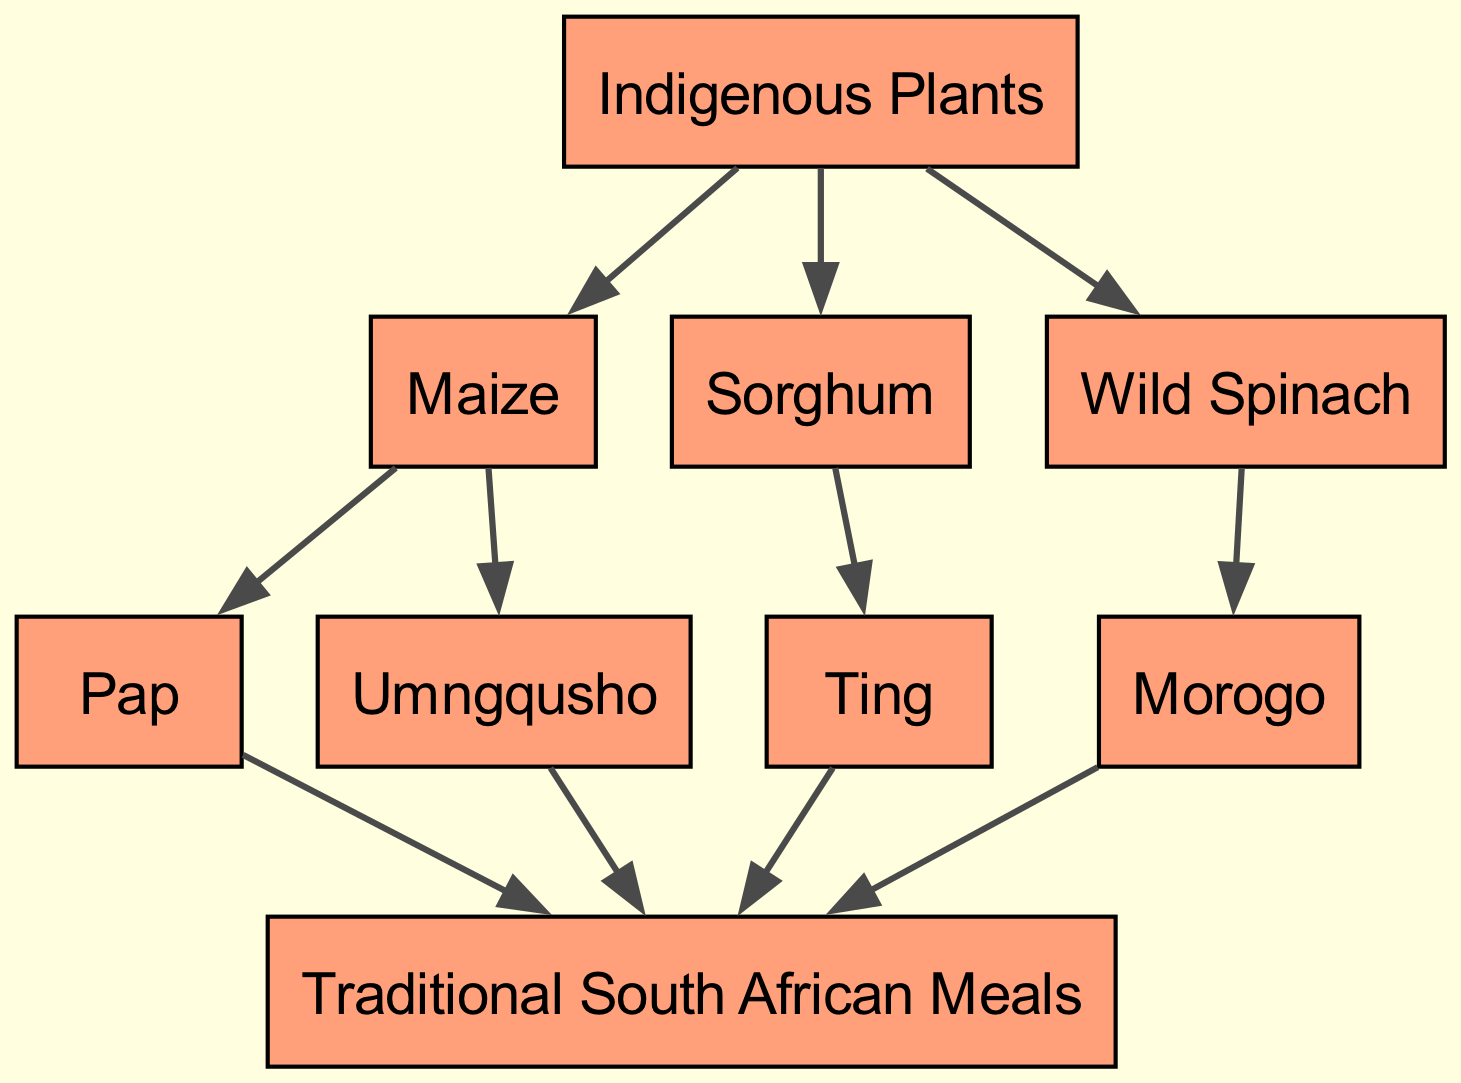What is the top node in the food chain? The top node represents the highest level in the hierarchy of the food chain, which in this case is "Traditional South African Meals."
Answer: Traditional South African Meals How many indigenous plants are shown in the diagram? To find the number of indigenous plants, we look at the first node, which has three children listed beneath it: Maize, Sorghum, and Wild Spinach, thus totaling three.
Answer: 3 Which indigenous plant leads to pap? By following the edges from the nodes, we see that "Pap" is a child of the "Maize" node, indicating that maize is the indigenous plant that leads to pap.
Answer: Maize Which dish is connected to both maize and sorghum? By examining the connections, we find that both "Pap" (from maize) and "Ting" (from sorghum) share a connection to "Traditional South African Meals," which makes "Traditional South African Meals" the common dish.
Answer: Traditional South African Meals What is the relationship between wild spinach and morogo? The relationship is that "Morogo" is the dish that is derived from "Wild Spinach," meaning wild spinach contributes to creating morogo.
Answer: Wild Spinach Which node has the most children? By checking the nodes, it is clear that "Indigenous Plants" is the only node with multiple children (Maize, Sorghum, Wild Spinach), totaling three, while others have fewer or none.
Answer: Indigenous Plants How many staple dishes are mentioned in connection with maize? The diagram shows two staple dishes connected to maize: "Pap" and "Umngqusho." Therefore, the answer is two.
Answer: 2 Is there a common meal resulting from multiple indigenous plants? Yes, the "Traditional South African Meals" node is the common meal that results from the indigenous plants: maize, sorghum, and wild spinach, as they all feed into this final node.
Answer: Traditional South African Meals What is the final product at the end of the food chain? The final product, or outcome, of this food chain diagram is indicated as "Traditional South African Meals," which represents the culmination of the traditional dishes derived from the indigenous plants.
Answer: Traditional South African Meals 